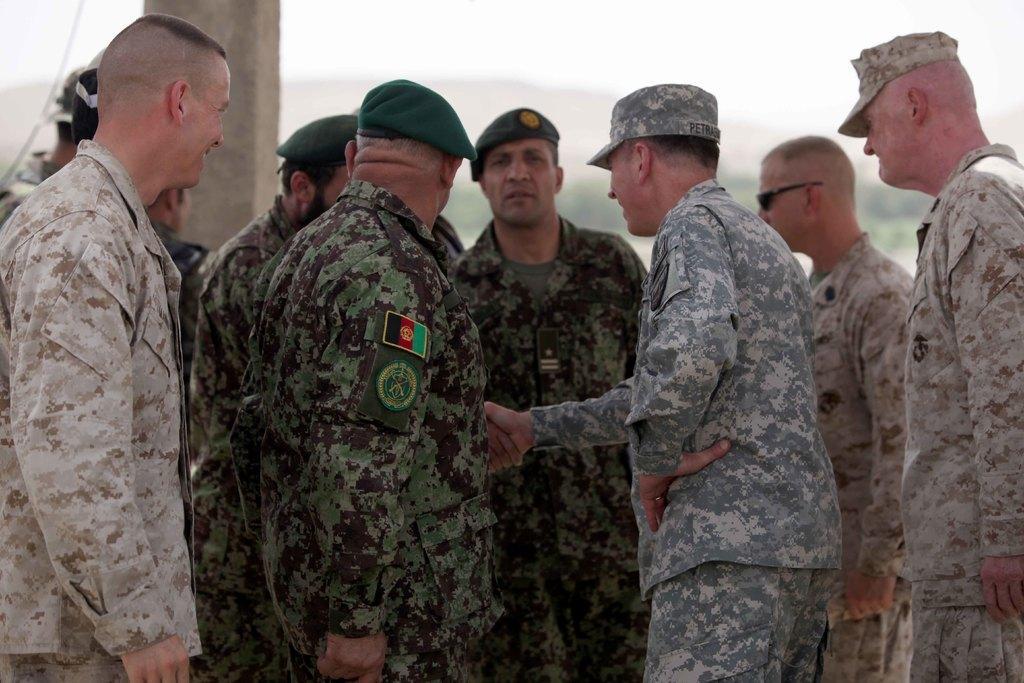Can you describe this image briefly? There is a group of persons standing as we can see in the middle of this image. There is one pillar beside to these persons. 